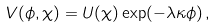<formula> <loc_0><loc_0><loc_500><loc_500>V ( \phi , \chi ) = U ( \chi ) \exp ( - \lambda \kappa \phi ) \, ,</formula> 